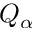<formula> <loc_0><loc_0><loc_500><loc_500>Q _ { \alpha }</formula> 